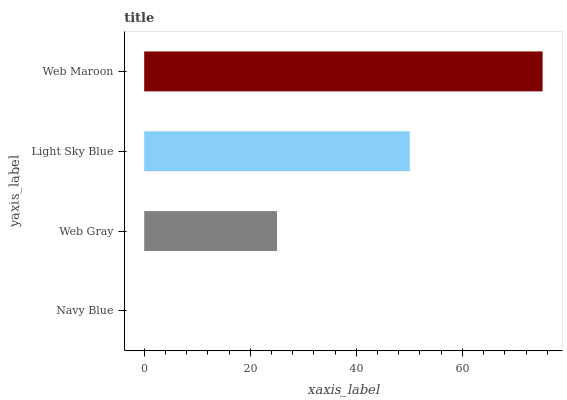Is Navy Blue the minimum?
Answer yes or no. Yes. Is Web Maroon the maximum?
Answer yes or no. Yes. Is Web Gray the minimum?
Answer yes or no. No. Is Web Gray the maximum?
Answer yes or no. No. Is Web Gray greater than Navy Blue?
Answer yes or no. Yes. Is Navy Blue less than Web Gray?
Answer yes or no. Yes. Is Navy Blue greater than Web Gray?
Answer yes or no. No. Is Web Gray less than Navy Blue?
Answer yes or no. No. Is Light Sky Blue the high median?
Answer yes or no. Yes. Is Web Gray the low median?
Answer yes or no. Yes. Is Web Gray the high median?
Answer yes or no. No. Is Light Sky Blue the low median?
Answer yes or no. No. 